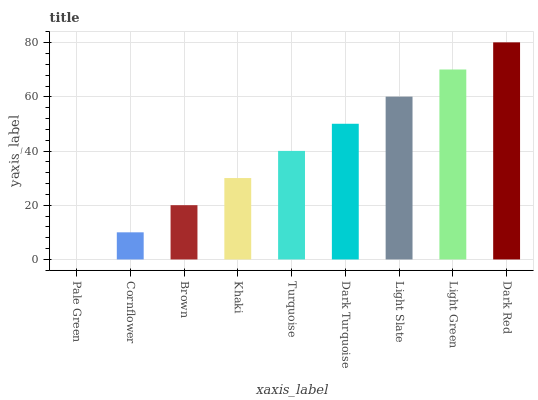Is Cornflower the minimum?
Answer yes or no. No. Is Cornflower the maximum?
Answer yes or no. No. Is Cornflower greater than Pale Green?
Answer yes or no. Yes. Is Pale Green less than Cornflower?
Answer yes or no. Yes. Is Pale Green greater than Cornflower?
Answer yes or no. No. Is Cornflower less than Pale Green?
Answer yes or no. No. Is Turquoise the high median?
Answer yes or no. Yes. Is Turquoise the low median?
Answer yes or no. Yes. Is Light Slate the high median?
Answer yes or no. No. Is Dark Turquoise the low median?
Answer yes or no. No. 